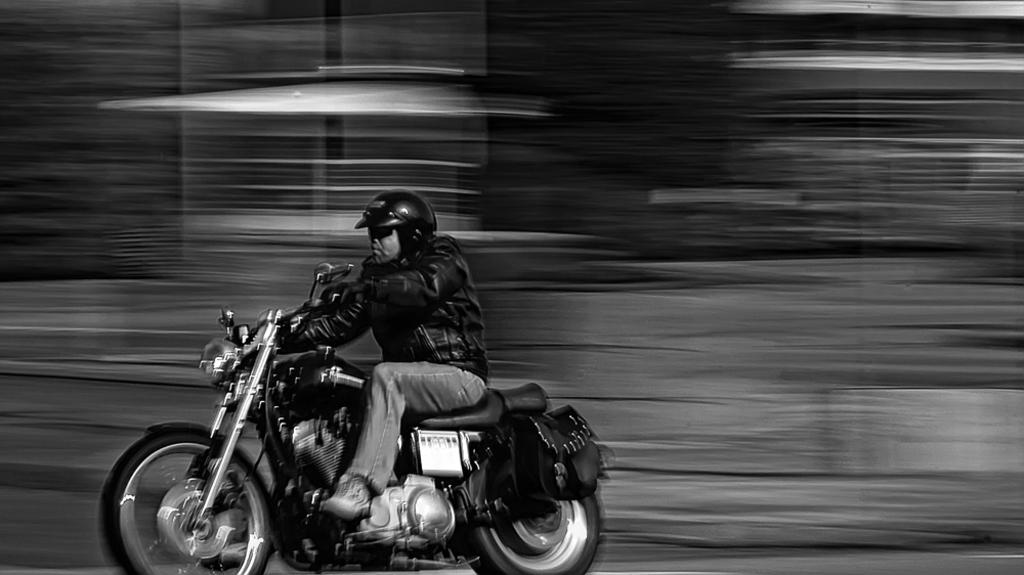What is the main object in the image? There is a bike in the image. What color is the bike? The bike is black in color. Is there anyone riding the bike? Yes, there is a man riding the bike. What type of knife is the man using to cut the idea in the image? There is no knife or idea present in the image; it features a man riding a black bike. 